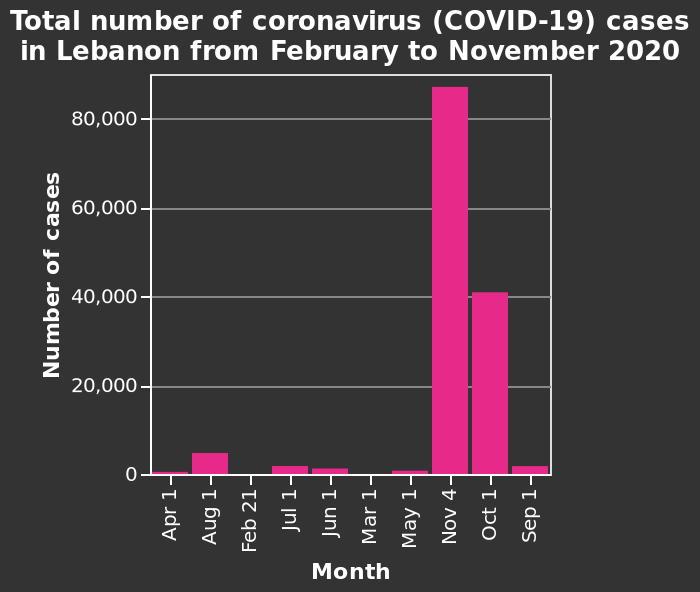<image>
What time period does the bar graph cover?  The bar graph covers the period from February to November 2020. What does the y-axis of the bar graph plot?  The y-axis plots the number of coronavirus (COVID-19) cases. How are the months represented on the x-axis? The categorical scale on the x-axis starts with Apr 1 and ends with Sep 1, marking each month. When did the virus start spreading rapidly? The virus started spreading rapidly from October. 